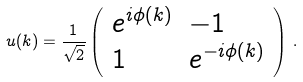<formula> <loc_0><loc_0><loc_500><loc_500>u ( k ) = \frac { 1 } { \sqrt { 2 } } \left ( \begin{array} { l l } e ^ { i \phi ( k ) } & - 1 \\ 1 & e ^ { - i \phi ( k ) } \end{array} \right ) \, .</formula> 